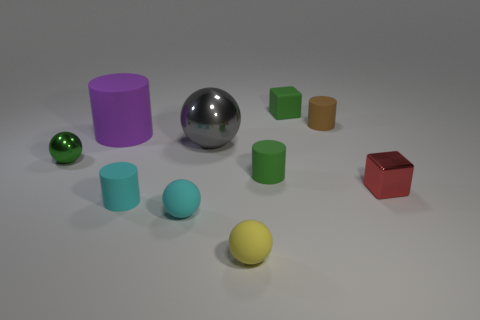Subtract all balls. How many objects are left? 6 Add 8 small yellow rubber cubes. How many small yellow rubber cubes exist? 8 Subtract 1 brown cylinders. How many objects are left? 9 Subtract all cyan objects. Subtract all large metal spheres. How many objects are left? 7 Add 6 small metal spheres. How many small metal spheres are left? 7 